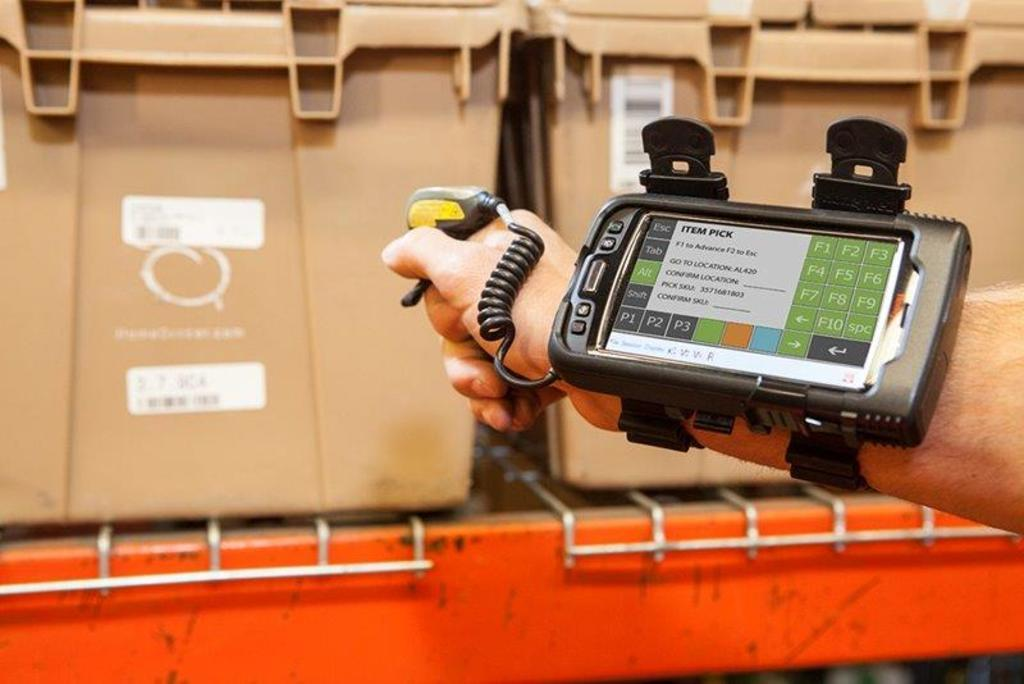Provide a one-sentence caption for the provided image. A worker wears a device that allows a scanner to be attached to his arm for the item pick. 